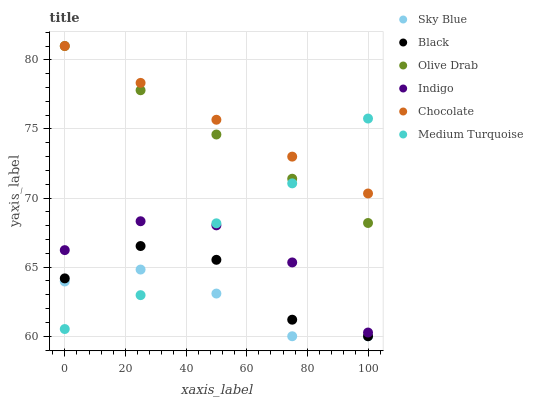Does Sky Blue have the minimum area under the curve?
Answer yes or no. Yes. Does Chocolate have the maximum area under the curve?
Answer yes or no. Yes. Does Black have the minimum area under the curve?
Answer yes or no. No. Does Black have the maximum area under the curve?
Answer yes or no. No. Is Olive Drab the smoothest?
Answer yes or no. Yes. Is Black the roughest?
Answer yes or no. Yes. Is Chocolate the smoothest?
Answer yes or no. No. Is Chocolate the roughest?
Answer yes or no. No. Does Black have the lowest value?
Answer yes or no. Yes. Does Chocolate have the lowest value?
Answer yes or no. No. Does Olive Drab have the highest value?
Answer yes or no. Yes. Does Black have the highest value?
Answer yes or no. No. Is Sky Blue less than Chocolate?
Answer yes or no. Yes. Is Chocolate greater than Indigo?
Answer yes or no. Yes. Does Medium Turquoise intersect Olive Drab?
Answer yes or no. Yes. Is Medium Turquoise less than Olive Drab?
Answer yes or no. No. Is Medium Turquoise greater than Olive Drab?
Answer yes or no. No. Does Sky Blue intersect Chocolate?
Answer yes or no. No. 